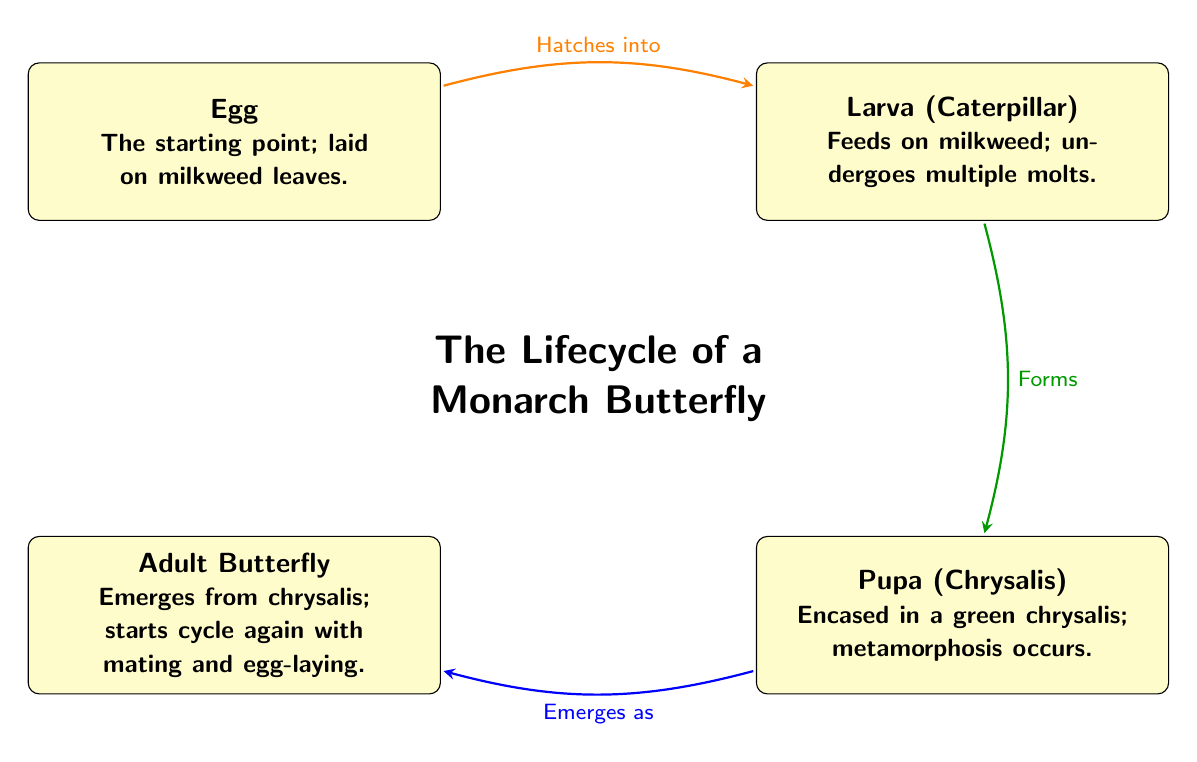What are the four stages of the Monarch Butterfly lifecycle? The diagram clearly shows four stages labeled as Egg, Larva, Pupa, and Adult Butterfly. These can be identified as distinct nodes in the lifecycle representation.
Answer: Egg, Larva, Pupa, Adult Butterfly What is the larva's primary food source? In the annotations associated with the Larva node, it specifies that the larva feeds on milkweed. This indicates what is necessary for the larva’s development during this stage.
Answer: Milkweed How many nodes are present in the diagram? By counting each lifecycle stage node, we recognize there are four distinct nodes: Egg, Larva, Pupa, and Adult Butterfly. Therefore, the total count of nodes is four.
Answer: 4 What transition occurs between Larva and Pupa? The diagram indicates the transition between Larva and Pupa with a note stating "Forms," which describes the process of the larva transforming into a pupa.
Answer: Forms Which stage emerges from the chrysalis? The diagram states that the Pupa (Chrysalis) stage has a transition indicated as "Emerges as," connecting it to the Adult Butterfly stage. This shows that an adult butterfly emerges from the chrysalis.
Answer: Adult Butterfly How are the lifecycle stages connected in the diagram? The diagram uses directed arrows to link each stage, indicating the progression through the lifecycle. For instance, the Egg stage points to the Larva stage and so on, highlighting the flow of development.
Answer: Directed arrows What is the color of the egg stage node? The Egg stage node in the diagram is filled with a yellow shade, making it visually distinct as the starting point of the lifecycle.
Answer: Yellow Which stage allows for mating and egg-laying? The Adult Butterfly stage is described as the one that starts the cycle again with mating and egg-laying, thus confirming its reproductive function in the lifecycle.
Answer: Adult Butterfly 